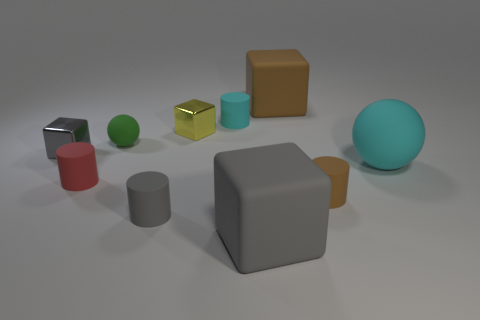Subtract all balls. How many objects are left? 8 Add 3 gray rubber objects. How many gray rubber objects exist? 5 Subtract 0 blue spheres. How many objects are left? 10 Subtract all cylinders. Subtract all purple metallic things. How many objects are left? 6 Add 7 small gray cylinders. How many small gray cylinders are left? 8 